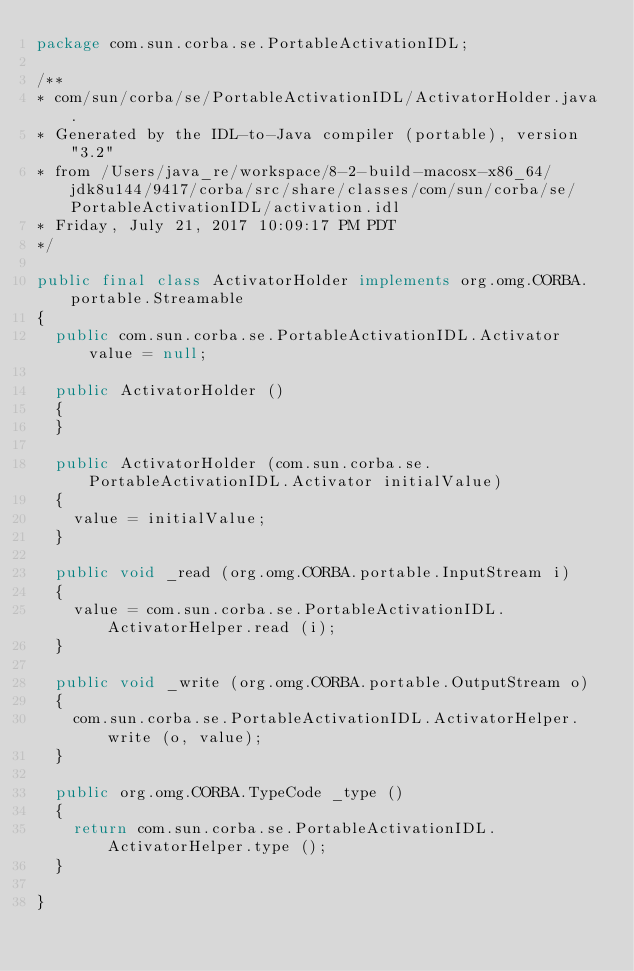Convert code to text. <code><loc_0><loc_0><loc_500><loc_500><_Java_>package com.sun.corba.se.PortableActivationIDL;

/**
* com/sun/corba/se/PortableActivationIDL/ActivatorHolder.java .
* Generated by the IDL-to-Java compiler (portable), version "3.2"
* from /Users/java_re/workspace/8-2-build-macosx-x86_64/jdk8u144/9417/corba/src/share/classes/com/sun/corba/se/PortableActivationIDL/activation.idl
* Friday, July 21, 2017 10:09:17 PM PDT
*/

public final class ActivatorHolder implements org.omg.CORBA.portable.Streamable
{
  public com.sun.corba.se.PortableActivationIDL.Activator value = null;

  public ActivatorHolder ()
  {
  }

  public ActivatorHolder (com.sun.corba.se.PortableActivationIDL.Activator initialValue)
  {
    value = initialValue;
  }

  public void _read (org.omg.CORBA.portable.InputStream i)
  {
    value = com.sun.corba.se.PortableActivationIDL.ActivatorHelper.read (i);
  }

  public void _write (org.omg.CORBA.portable.OutputStream o)
  {
    com.sun.corba.se.PortableActivationIDL.ActivatorHelper.write (o, value);
  }

  public org.omg.CORBA.TypeCode _type ()
  {
    return com.sun.corba.se.PortableActivationIDL.ActivatorHelper.type ();
  }

}
</code> 